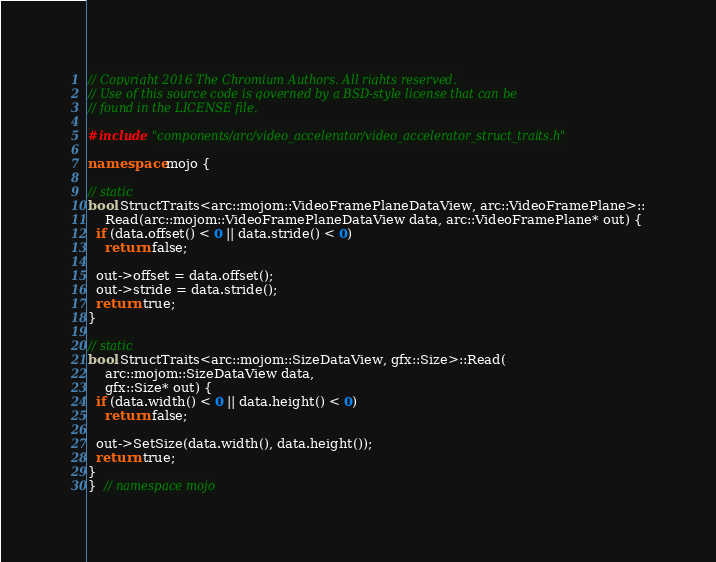Convert code to text. <code><loc_0><loc_0><loc_500><loc_500><_C++_>// Copyright 2016 The Chromium Authors. All rights reserved.
// Use of this source code is governed by a BSD-style license that can be
// found in the LICENSE file.

#include "components/arc/video_accelerator/video_accelerator_struct_traits.h"

namespace mojo {

// static
bool StructTraits<arc::mojom::VideoFramePlaneDataView, arc::VideoFramePlane>::
    Read(arc::mojom::VideoFramePlaneDataView data, arc::VideoFramePlane* out) {
  if (data.offset() < 0 || data.stride() < 0)
    return false;

  out->offset = data.offset();
  out->stride = data.stride();
  return true;
}

// static
bool StructTraits<arc::mojom::SizeDataView, gfx::Size>::Read(
    arc::mojom::SizeDataView data,
    gfx::Size* out) {
  if (data.width() < 0 || data.height() < 0)
    return false;

  out->SetSize(data.width(), data.height());
  return true;
}
}  // namespace mojo
</code> 